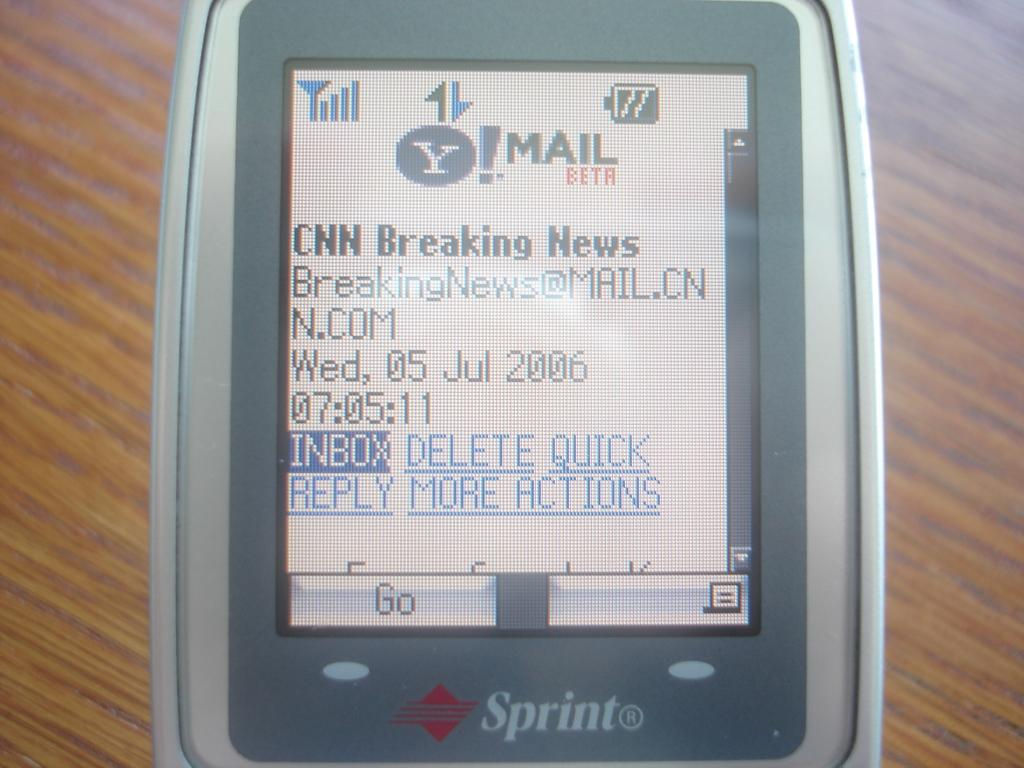<image>
Relay a brief, clear account of the picture shown. An older Sprint phone displaying a CNN Breaking News headline. 